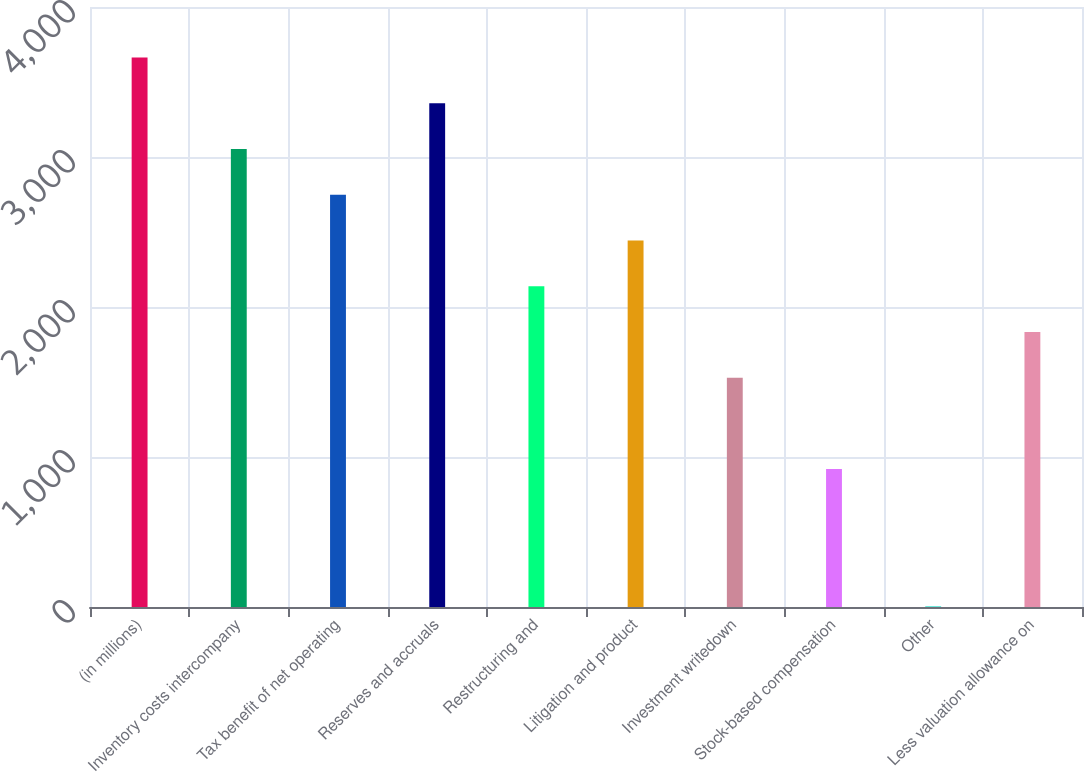<chart> <loc_0><loc_0><loc_500><loc_500><bar_chart><fcel>(in millions)<fcel>Inventory costs intercompany<fcel>Tax benefit of net operating<fcel>Reserves and accruals<fcel>Restructuring and<fcel>Litigation and product<fcel>Investment writedown<fcel>Stock-based compensation<fcel>Other<fcel>Less valuation allowance on<nl><fcel>3662.6<fcel>3053<fcel>2748.2<fcel>3357.8<fcel>2138.6<fcel>2443.4<fcel>1529<fcel>919.4<fcel>5<fcel>1833.8<nl></chart> 